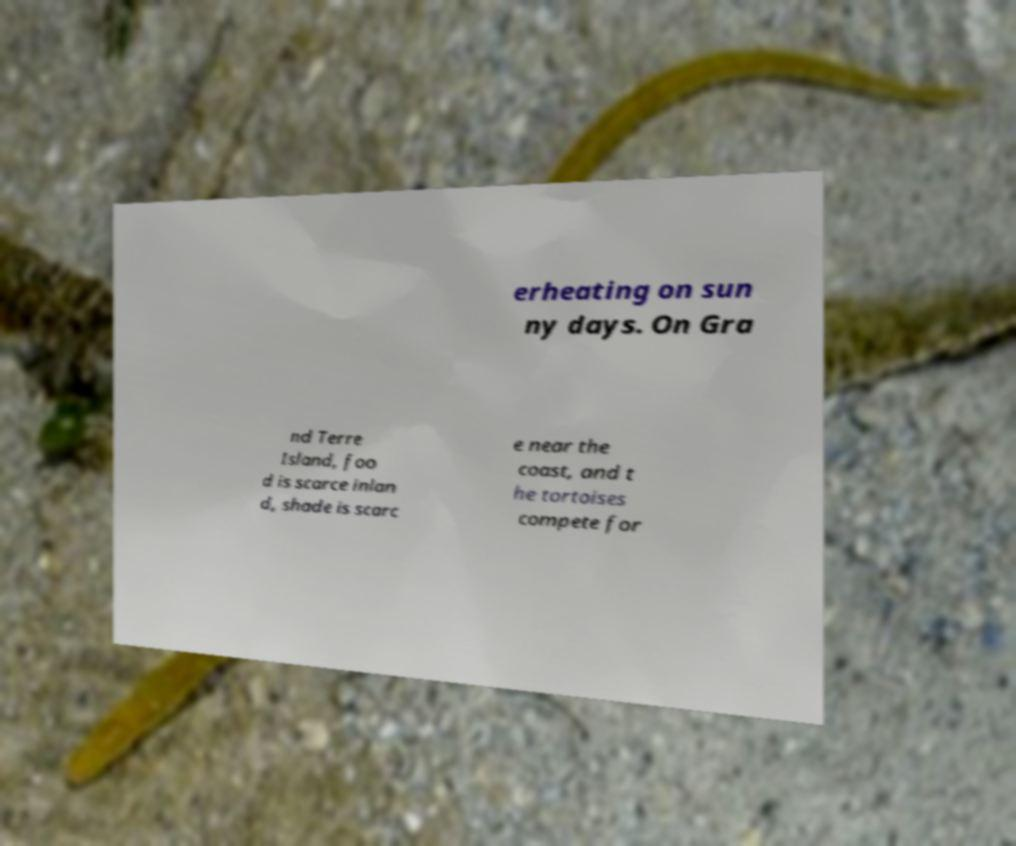Could you assist in decoding the text presented in this image and type it out clearly? erheating on sun ny days. On Gra nd Terre Island, foo d is scarce inlan d, shade is scarc e near the coast, and t he tortoises compete for 